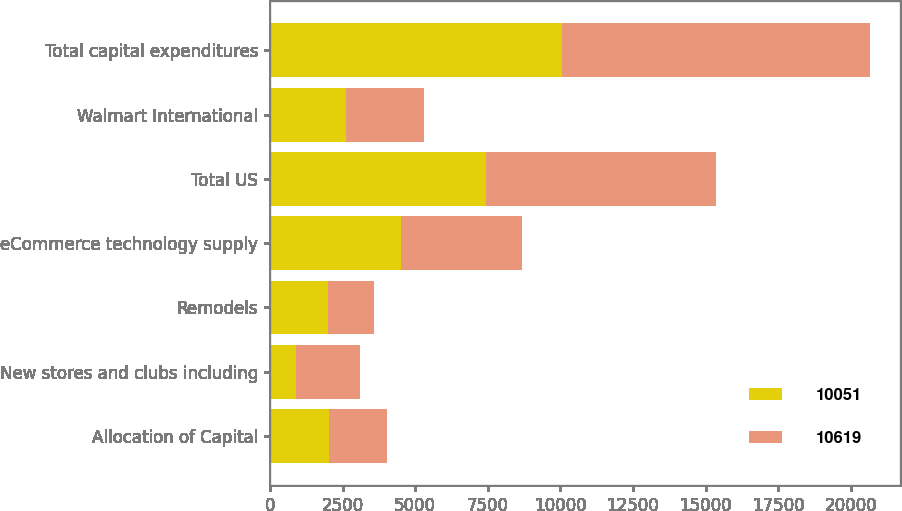<chart> <loc_0><loc_0><loc_500><loc_500><stacked_bar_chart><ecel><fcel>Allocation of Capital<fcel>New stores and clubs including<fcel>Remodels<fcel>eCommerce technology supply<fcel>Total US<fcel>Walmart International<fcel>Total capital expenditures<nl><fcel>10051<fcel>2018<fcel>914<fcel>2009<fcel>4521<fcel>7444<fcel>2607<fcel>10051<nl><fcel>10619<fcel>2017<fcel>2171<fcel>1589<fcel>4162<fcel>7922<fcel>2697<fcel>10619<nl></chart> 